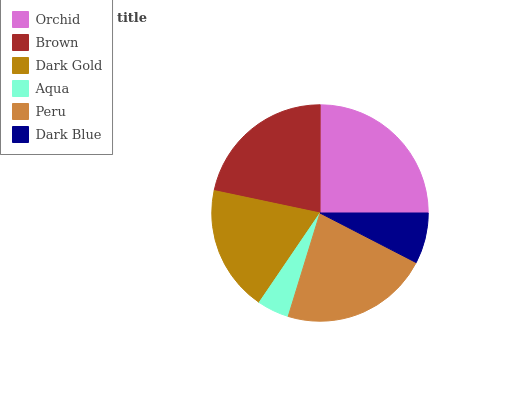Is Aqua the minimum?
Answer yes or no. Yes. Is Orchid the maximum?
Answer yes or no. Yes. Is Brown the minimum?
Answer yes or no. No. Is Brown the maximum?
Answer yes or no. No. Is Orchid greater than Brown?
Answer yes or no. Yes. Is Brown less than Orchid?
Answer yes or no. Yes. Is Brown greater than Orchid?
Answer yes or no. No. Is Orchid less than Brown?
Answer yes or no. No. Is Brown the high median?
Answer yes or no. Yes. Is Dark Gold the low median?
Answer yes or no. Yes. Is Aqua the high median?
Answer yes or no. No. Is Brown the low median?
Answer yes or no. No. 